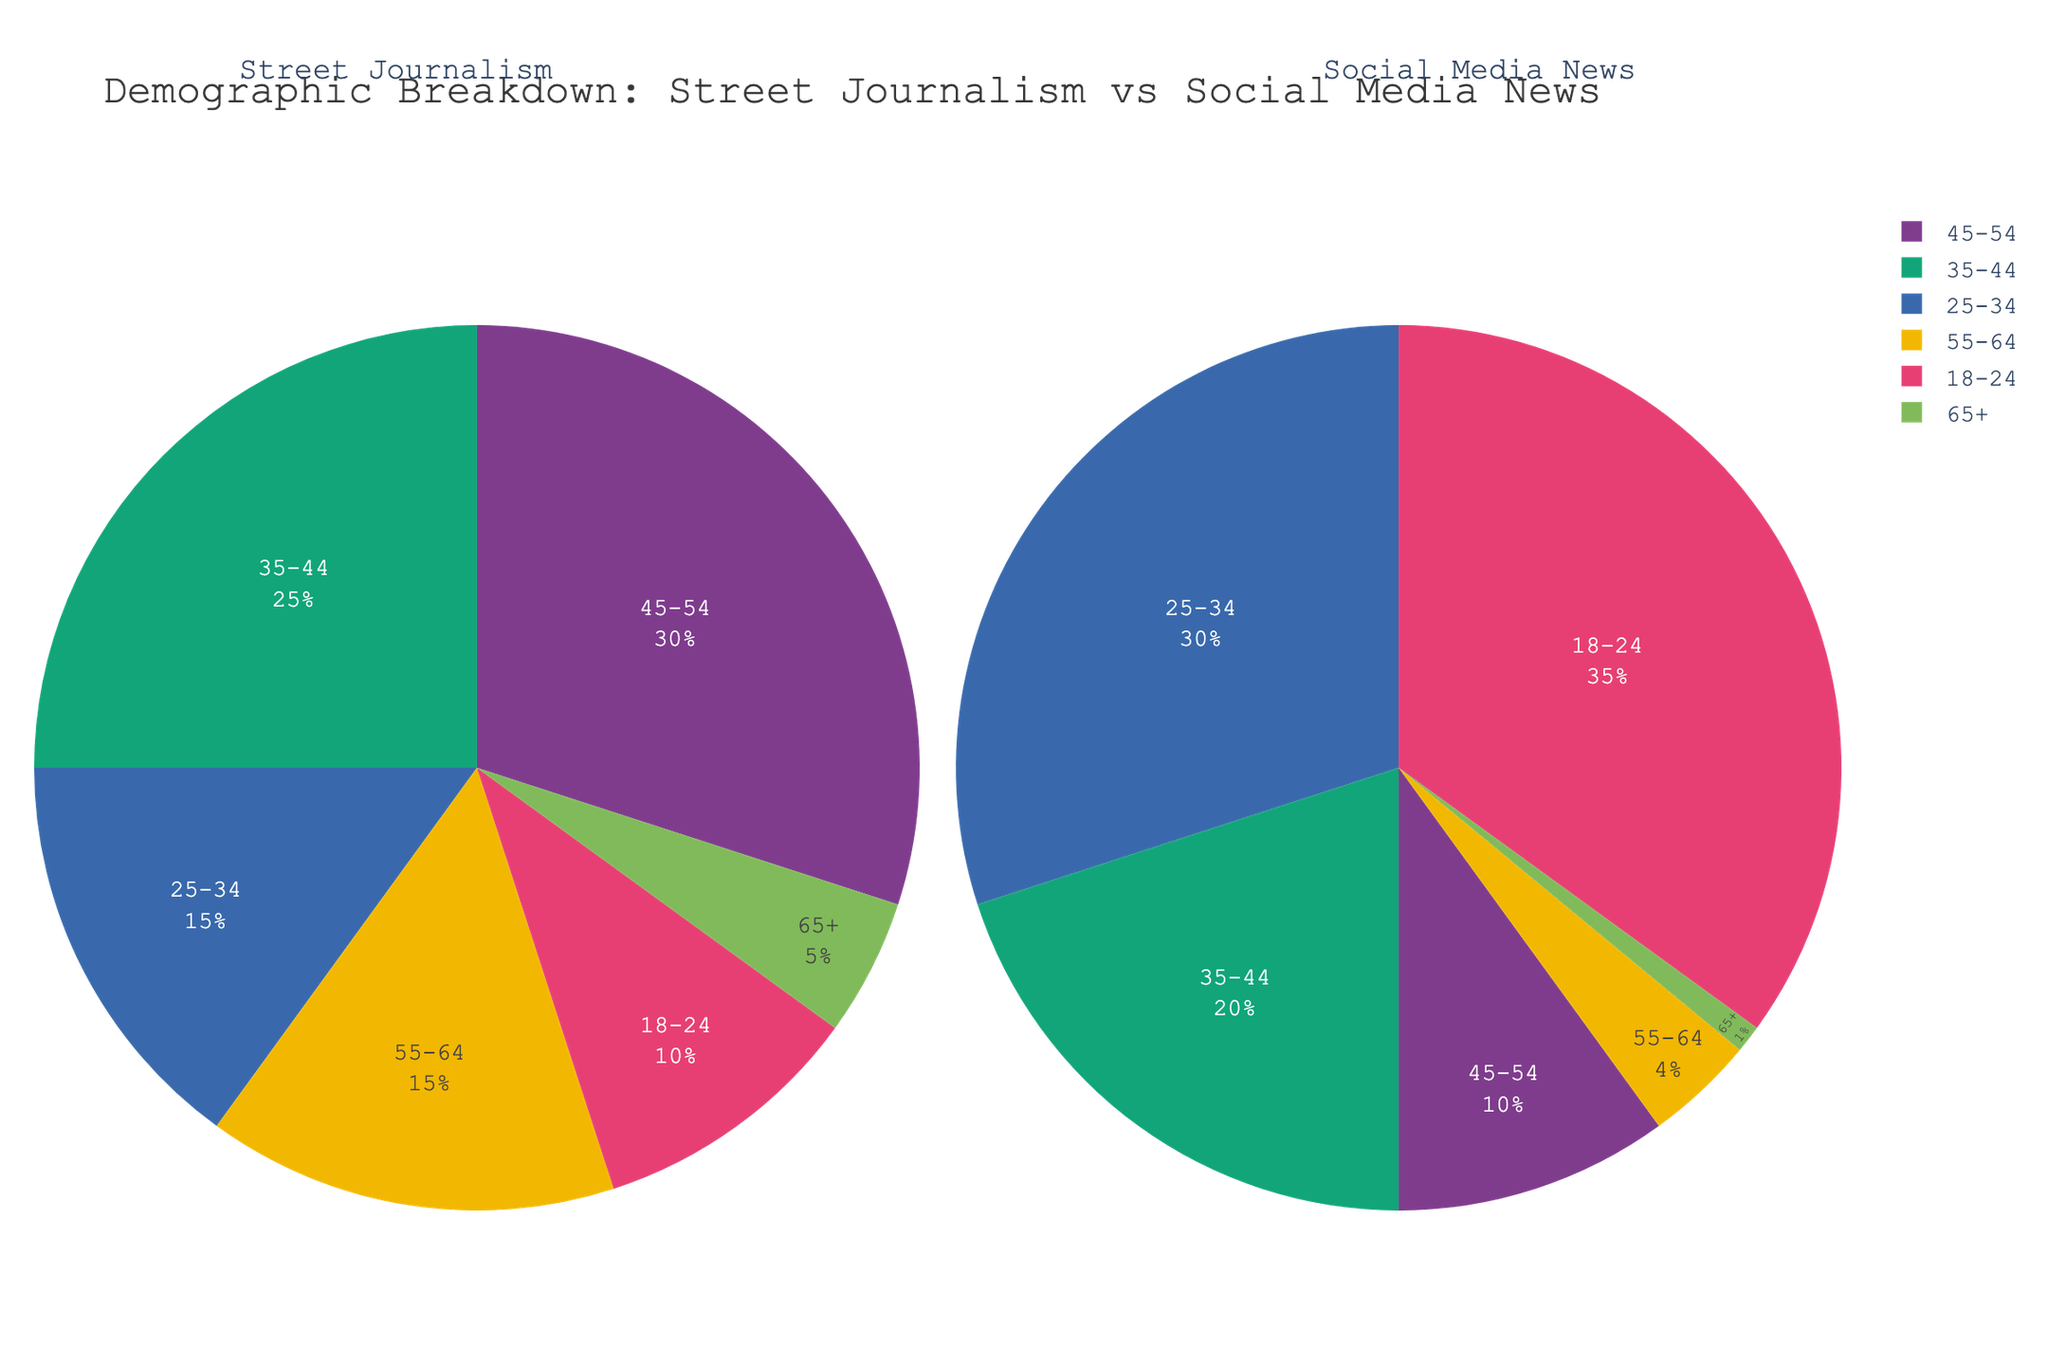What percentage of the audience for street journalism is aged 45-54? Look at the pie chart section labeled '45-54' for the 'Street Journalism' facet.
Answer: 30% Which age group has the highest percentage of the social media news audience? Identify the largest pie slice in the 'Social Media News' facet. The label for this slice is '18-24'.
Answer: 18-24 How much larger is the percentage of the 25-34 age group in social media news compared to street journalism? Find the percentage for both sources in the 25-34 age group and subtract the street journalism value from the social media news value (30% - 15% = 15%).
Answer: 15% What is the total percentage for the street journalism audience aged 35-44 and 45-54 combined? Add the percentages of the 35-44 and 45-54 age groups for street journalism (25% + 30% = 55%).
Answer: 55% Which age group has the lowest percentage in both street journalism and social media news? Identify the smallest pie slices in both facets, which are labeled '65+'.
Answer: 65+ What's the combined percentage of the street journalism audience aged under 35? Add the percentages for the 18-24 and 25-34 age groups in the street journalism facet (10% + 15% = 25%).
Answer: 25% How does the percentage of the 55-64 age group in street journalism compare to social media news? Compare the percentages of the 55-64 age group in both sources: Street Journalism is 15%, Social Media News is 4%. The percentage for street journalism is higher.
Answer: Street Journalism is higher What percentage of the social media news audience is aged 35-54? Add the percentages of the 35-44 and 45-54 age groups for social media news (20% + 10% = 30%).
Answer: 30% Which facet has a higher percentage of audience members aged over 55? Compare the percentages for the 55-64 and 65+ age groups in both facets. Street Journalism has 15% + 5% = 20%, Social Media News has 4% + 1% = 5%.
Answer: Street Journalism 